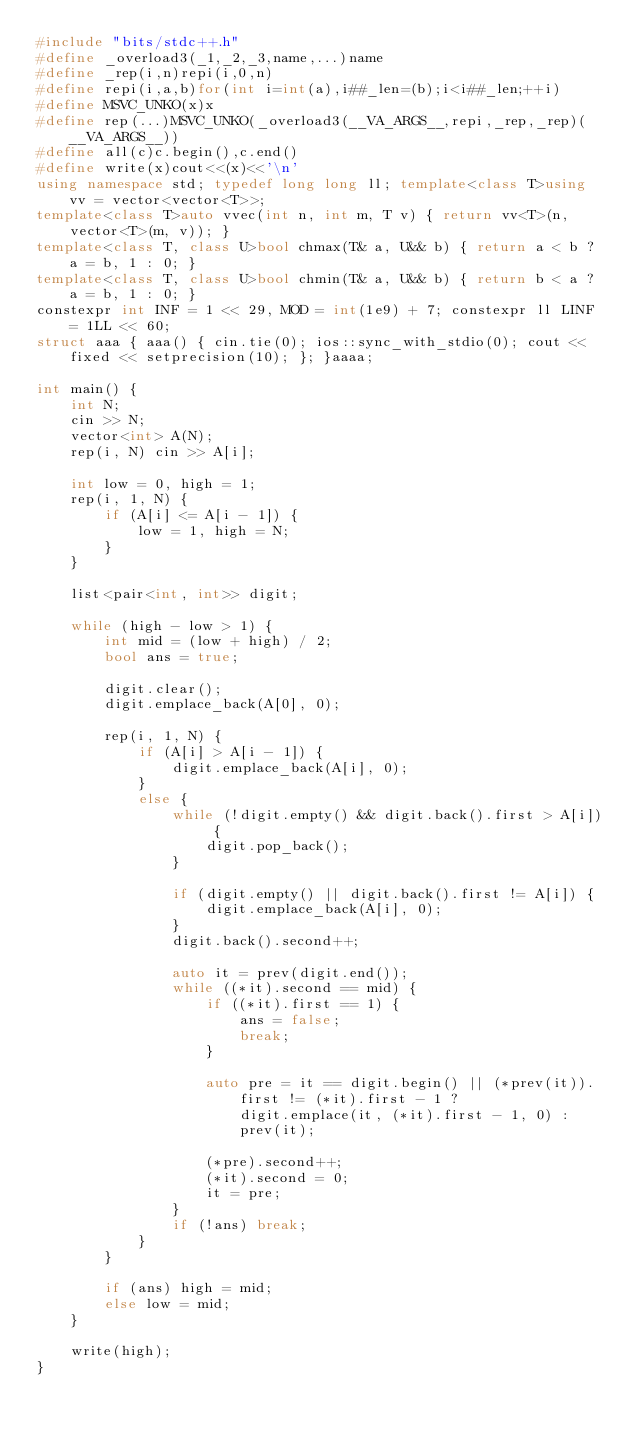Convert code to text. <code><loc_0><loc_0><loc_500><loc_500><_C++_>#include "bits/stdc++.h"
#define _overload3(_1,_2,_3,name,...)name
#define _rep(i,n)repi(i,0,n)
#define repi(i,a,b)for(int i=int(a),i##_len=(b);i<i##_len;++i)
#define MSVC_UNKO(x)x
#define rep(...)MSVC_UNKO(_overload3(__VA_ARGS__,repi,_rep,_rep)(__VA_ARGS__))
#define all(c)c.begin(),c.end()
#define write(x)cout<<(x)<<'\n'
using namespace std; typedef long long ll; template<class T>using vv = vector<vector<T>>;
template<class T>auto vvec(int n, int m, T v) { return vv<T>(n, vector<T>(m, v)); }
template<class T, class U>bool chmax(T& a, U&& b) { return a < b ? a = b, 1 : 0; }
template<class T, class U>bool chmin(T& a, U&& b) { return b < a ? a = b, 1 : 0; }
constexpr int INF = 1 << 29, MOD = int(1e9) + 7; constexpr ll LINF = 1LL << 60;
struct aaa { aaa() { cin.tie(0); ios::sync_with_stdio(0); cout << fixed << setprecision(10); }; }aaaa;

int main() {
    int N;
    cin >> N;
    vector<int> A(N);
    rep(i, N) cin >> A[i];

    int low = 0, high = 1;
    rep(i, 1, N) {
        if (A[i] <= A[i - 1]) {
            low = 1, high = N;
        }
    }

    list<pair<int, int>> digit;

    while (high - low > 1) {
        int mid = (low + high) / 2;
        bool ans = true;

        digit.clear();
        digit.emplace_back(A[0], 0);

        rep(i, 1, N) {
            if (A[i] > A[i - 1]) {
                digit.emplace_back(A[i], 0);
            }
            else {
                while (!digit.empty() && digit.back().first > A[i]) {
                    digit.pop_back();
                }

                if (digit.empty() || digit.back().first != A[i]) {
                    digit.emplace_back(A[i], 0);
                }
                digit.back().second++;

                auto it = prev(digit.end());
                while ((*it).second == mid) {
                    if ((*it).first == 1) {
                        ans = false;
                        break;
                    }

                    auto pre = it == digit.begin() || (*prev(it)).first != (*it).first - 1 ?
                        digit.emplace(it, (*it).first - 1, 0) :
                        prev(it);

                    (*pre).second++;
                    (*it).second = 0;
                    it = pre;
                }
                if (!ans) break;
            }
        }

        if (ans) high = mid;
        else low = mid;
    }

    write(high);
}</code> 